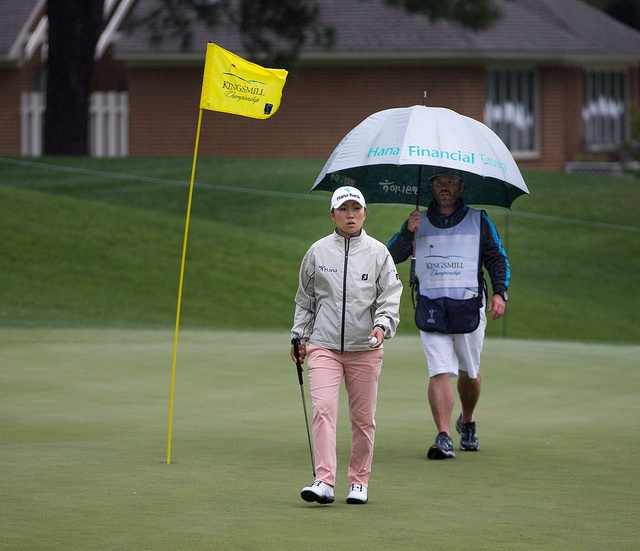Describe the objects in this image and their specific colors. I can see people in black, darkgray, lightgray, and gray tones, people in black, darkgray, and gray tones, umbrella in black, lavender, lightblue, and gray tones, handbag in black, navy, gray, and darkgreen tones, and sports ball in black, lavender, gray, and darkgray tones in this image. 